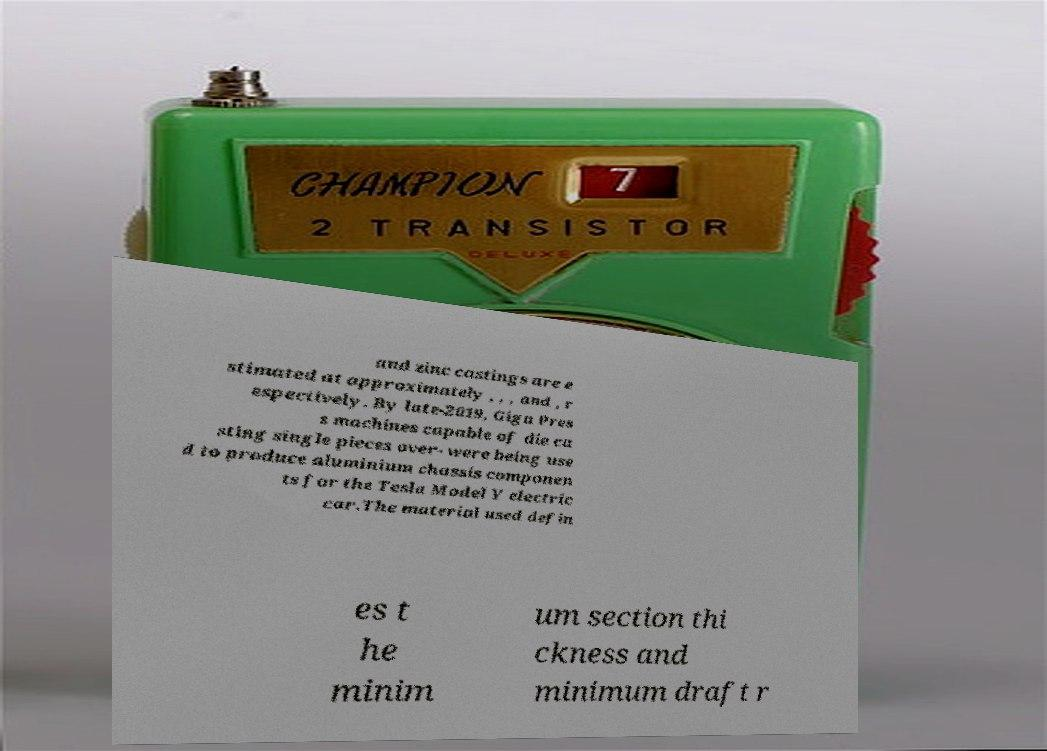Can you read and provide the text displayed in the image?This photo seems to have some interesting text. Can you extract and type it out for me? and zinc castings are e stimated at approximately , , , and , r espectively. By late-2019, Giga Pres s machines capable of die ca sting single pieces over- were being use d to produce aluminium chassis componen ts for the Tesla Model Y electric car.The material used defin es t he minim um section thi ckness and minimum draft r 